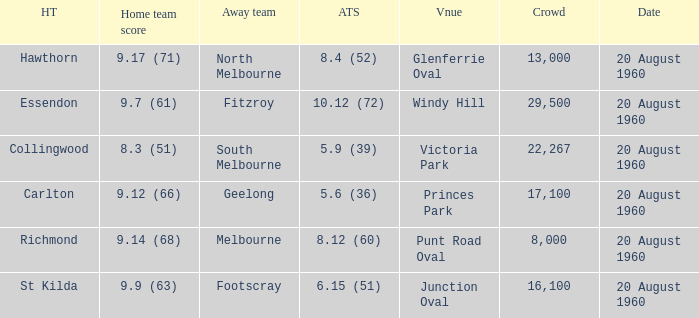What is the venue when Geelong is the away team? Princes Park. Parse the full table. {'header': ['HT', 'Home team score', 'Away team', 'ATS', 'Vnue', 'Crowd', 'Date'], 'rows': [['Hawthorn', '9.17 (71)', 'North Melbourne', '8.4 (52)', 'Glenferrie Oval', '13,000', '20 August 1960'], ['Essendon', '9.7 (61)', 'Fitzroy', '10.12 (72)', 'Windy Hill', '29,500', '20 August 1960'], ['Collingwood', '8.3 (51)', 'South Melbourne', '5.9 (39)', 'Victoria Park', '22,267', '20 August 1960'], ['Carlton', '9.12 (66)', 'Geelong', '5.6 (36)', 'Princes Park', '17,100', '20 August 1960'], ['Richmond', '9.14 (68)', 'Melbourne', '8.12 (60)', 'Punt Road Oval', '8,000', '20 August 1960'], ['St Kilda', '9.9 (63)', 'Footscray', '6.15 (51)', 'Junction Oval', '16,100', '20 August 1960']]} 